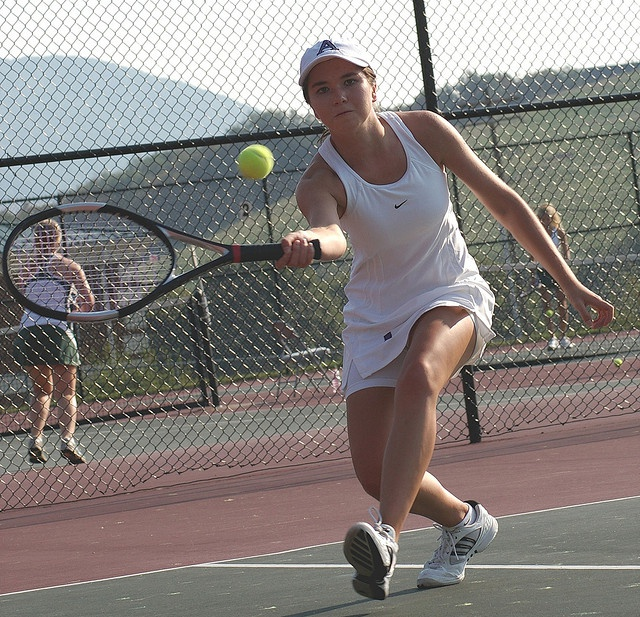Describe the objects in this image and their specific colors. I can see people in lightgray, gray, maroon, and darkgray tones, tennis racket in lightgray, gray, black, and darkgray tones, people in lightgray, black, gray, darkgray, and maroon tones, people in lightgray, gray, black, and darkgray tones, and sports ball in lightgray, olive, and khaki tones in this image. 